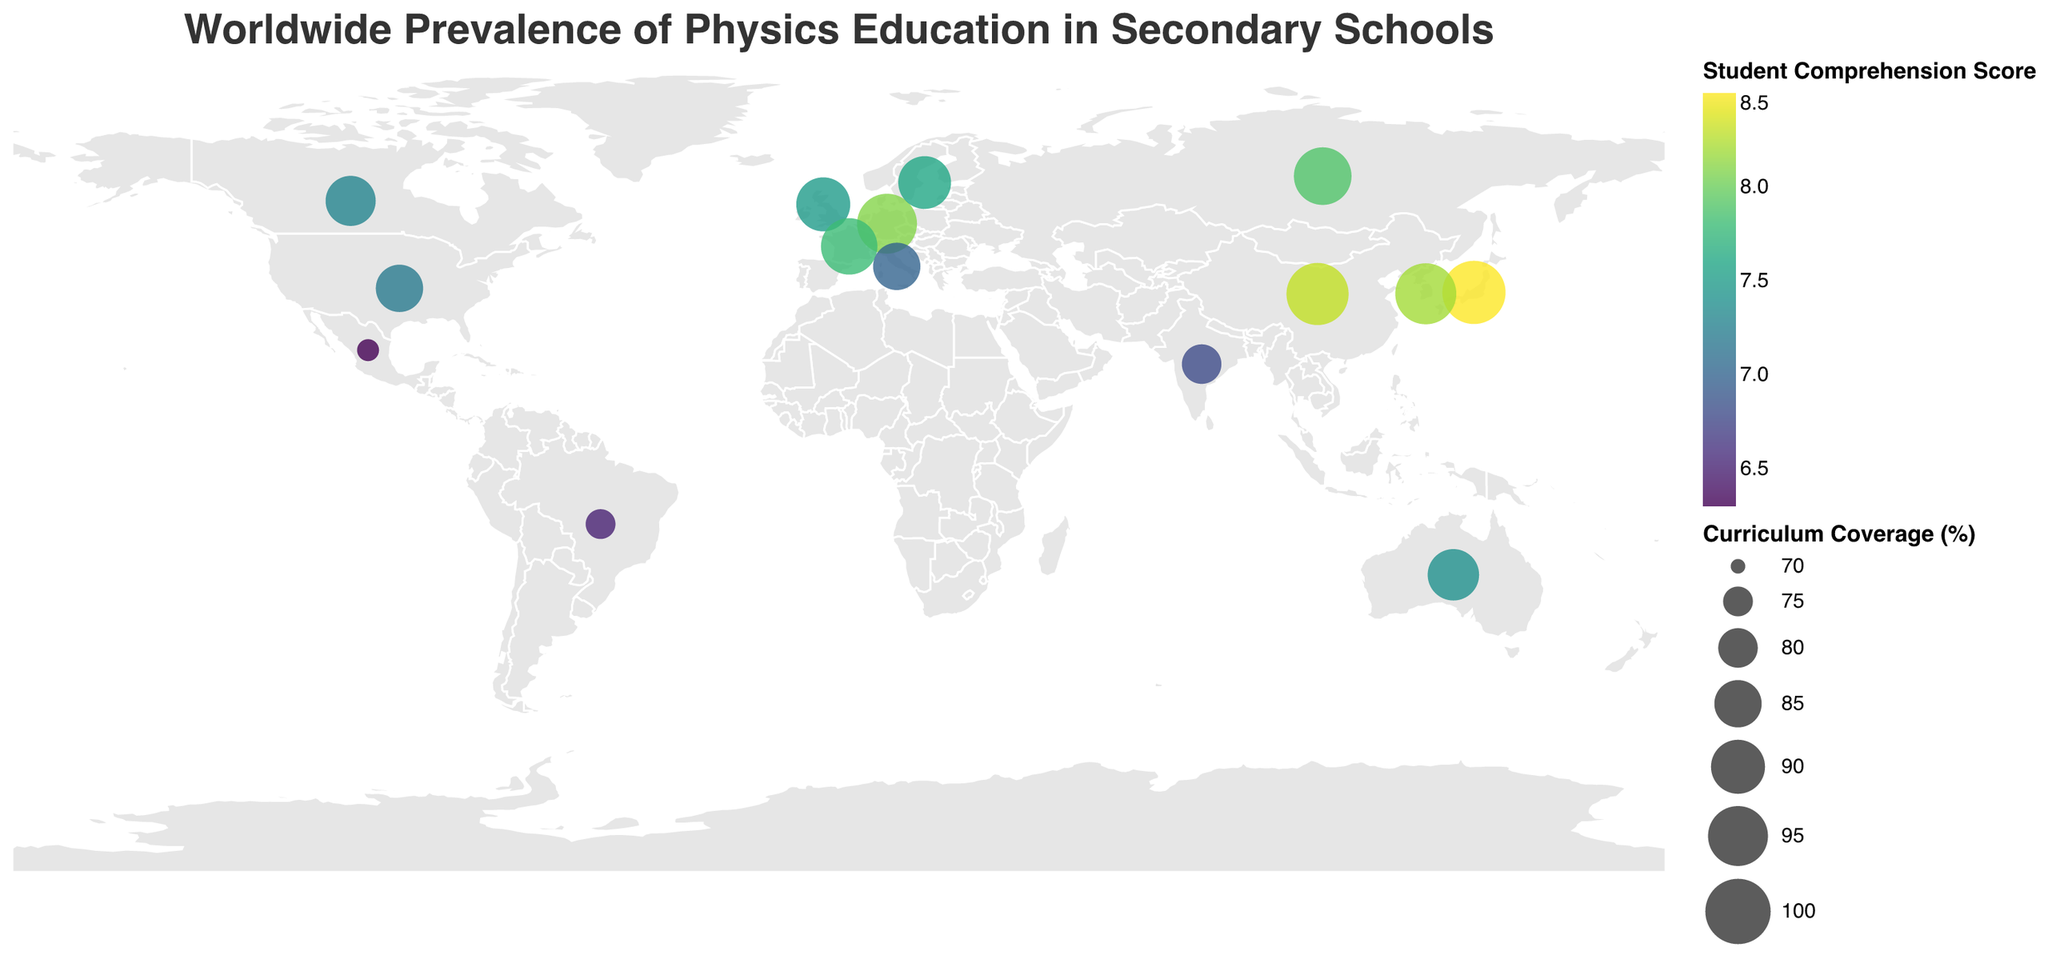Which country has the highest curriculum coverage percentage? To find this, look for the largest circle size on the plot. The tooltip shows that Japan has the highest curriculum coverage percentage of 98%.
Answer: Japan Which country has the lowest student comprehension score? Check the tooltip of the smallest and/or lightest-colored circles to find out the student comprehension scores. Mexico has the lowest student comprehension score of 6.3.
Answer: Mexico What is the average curriculum coverage percentage of countries with student comprehension scores above 8.0? Identify countries with comprehension scores above 8.0 (Germany, Japan, China, South Korea). Their curriculum coverage percentages are 95, 98, 97, 96 respectively. Calculate the average: (95+98+97+96)/4 = 96.5.
Answer: 96.5% Which country spends the most average hours on physics education? Look at the tooltip information for each circle to find the average hours spent. China spends the most with 60 hours.
Answer: China How does student comprehension score compare between the United States and France? Check the tooltips for both countries. The United States has a student comprehension score of 7.2, while France has 7.8.
Answer: France's score is higher What is the range of curriculum coverage percentages shown in the plot? Identify the highest and lowest curriculum coverage percentages: 98% (Japan) and 72% (Mexico). The difference is: 98 - 72 = 26.
Answer: 26 Which three countries have the largest difference in average hours spent on physics education? Calculate differences for countries listed: China (60) - Mexico (28) = 32; Japan (55) - Mexico (28) = 27; South Korea (52) - Mexico (28) = 24. The largest differences are China-Mexico (32), Japan-Mexico (27), South Korea-Mexico (24).
Answer: China, Japan, South Korea (all compared to Mexico) Which country has similar curriculum coverage to Canada but a better student comprehension score? Canada has a curriculum coverage of 87%. Sweden (89%), Australia (88%) have similar coverage. Sweden has a score of 7.6, which is better compared to Canada’s 7.3.
Answer: Sweden What is the relationship between average hours spent and student comprehension score across countries? By inspecting the color gradient and hover tooltips: higher average hours spent tends to correlate with higher student comprehension scores, indicated by darker colors and larger circle sizes.
Answer: Positive correlation Which region appears to emphasize physics education the most based on curriculum coverage and student comprehension score? Look for tightly clustered large, dark circles (high curriculum coverage and comprehension scores). East Asia (Japan, China, South Korea) shows high emphasis on physics education.
Answer: East Asia (Japan, China, South Korea) How does curriculum coverage percentage in the United Kingdom compare with Australia? Check the tooltips for both countries. United Kingdom has a curriculum coverage percentage of 90%, while Australia has 88%.
Answer: United Kingdom's is slightly higher 